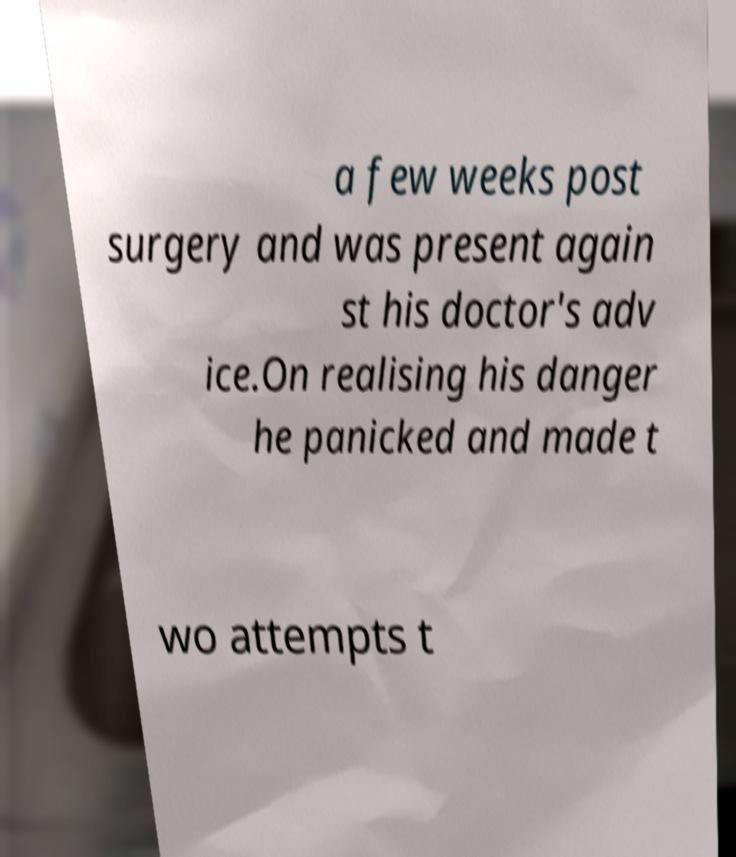Please identify and transcribe the text found in this image. a few weeks post surgery and was present again st his doctor's adv ice.On realising his danger he panicked and made t wo attempts t 